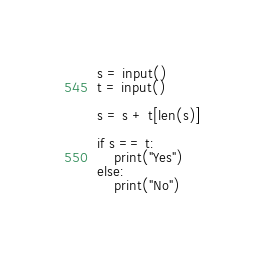Convert code to text. <code><loc_0><loc_0><loc_500><loc_500><_Python_>s = input()
t = input()

s = s + t[len(s)]

if s == t:
    print("Yes")
else:
    print("No")
</code> 